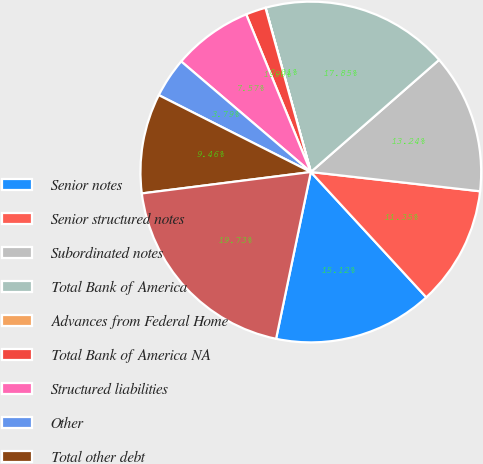Convert chart to OTSL. <chart><loc_0><loc_0><loc_500><loc_500><pie_chart><fcel>Senior notes<fcel>Senior structured notes<fcel>Subordinated notes<fcel>Total Bank of America<fcel>Advances from Federal Home<fcel>Total Bank of America NA<fcel>Structured liabilities<fcel>Other<fcel>Total other debt<fcel>Total long-term debt excluding<nl><fcel>15.12%<fcel>11.35%<fcel>13.24%<fcel>17.85%<fcel>0.01%<fcel>1.9%<fcel>7.57%<fcel>3.79%<fcel>9.46%<fcel>19.73%<nl></chart> 